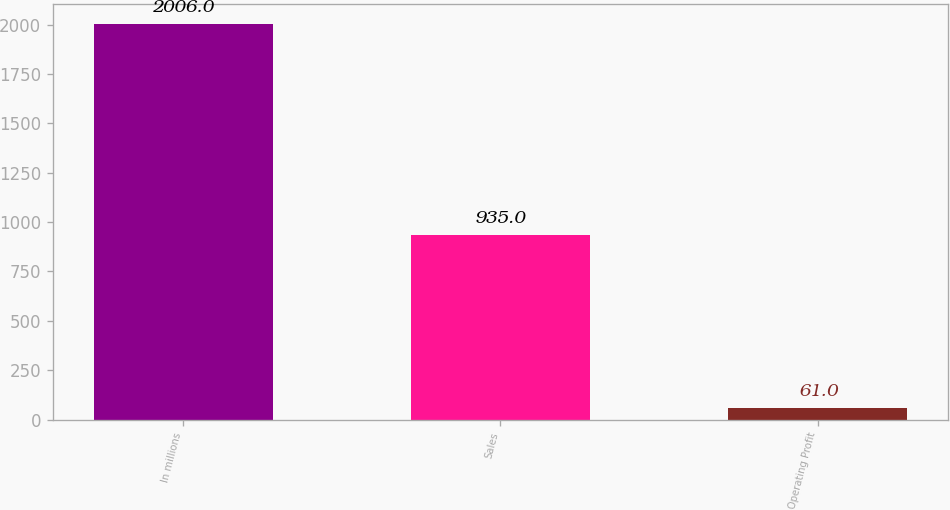<chart> <loc_0><loc_0><loc_500><loc_500><bar_chart><fcel>In millions<fcel>Sales<fcel>Operating Profit<nl><fcel>2006<fcel>935<fcel>61<nl></chart> 